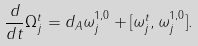<formula> <loc_0><loc_0><loc_500><loc_500>\frac { d } { d t } \Omega ^ { t } _ { j } = d _ { A } \omega ^ { 1 , 0 } _ { j } + [ \omega ^ { t } _ { j } , \omega ^ { 1 , 0 } _ { j } ] .</formula> 